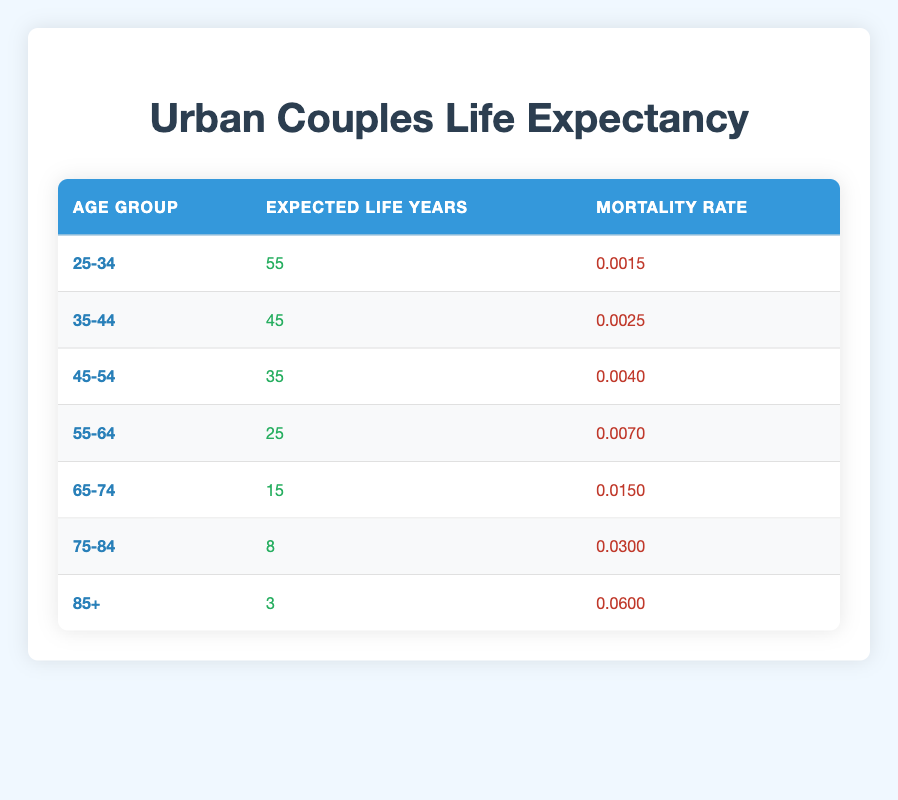What is the expected life span for couples aged 25-34? The table shows that for the age group 25-34, the expected life years are listed as 55. Therefore, the expected life span for this age group is 55 years.
Answer: 55 years What is the highest mortality rate among the age groups listed? By reviewing the mortality rates for each age group, the highest value is found in the age group 85+, which has a mortality rate of 0.0600.
Answer: 0.0600 How many total life years can couples expect to live from ages 35-54 combined? To find the total life years for age groups 35-44 and 45-54, we add their expected life years: 45 (from 35-44) + 35 (from 45-54) = 80.
Answer: 80 years Is the expected life years for the age group 55-64 greater than the average expected life years of the age groups provided? The average expected life years can be calculated by summing all expected life years: 55 + 45 + 35 + 25 + 15 + 8 + 3 = 186, then dividing by 7 gives 186 / 7 ≈ 26.57. Since 25 (for 55-64) is less than 26.57, the answer is no, it’s not greater.
Answer: No What is the difference in expected life years between the 45-54 age group and the 65-74 age group? The expected life years for 45-54 is 35 and for 65-74 is 15. To find the difference, subtract 15 from 35: 35 - 15 = 20.
Answer: 20 years What percentage increase is there in expected life years from the 75-84 age group to the 55-64 age group? The expected life years for 55-64 is 25 and for 75-84 is 8. The increase is 25 - 8 = 17. To find the percentage increase relative to 8, use the formula: (17 / 8) * 100 ≈ 212.5%.
Answer: 212.5% Are there any age groups where the expected life years is less than the associated mortality rate value? By comparing the expected life years to the mortality rates, we find for age groups 25-34 (55 < 0.0015), 35-44 (45 < 0.0025), 45-54 (35 < 0.004), and 55-64 (25 < 0.007) do not meet this condition. However, for the age group 85+, 3 is indeed less than 0.0600, so the answer is no for others and yes for this group.
Answer: Yes How many life years do couples aged 65-74 have remaining compared to those aged 75-84? From the table, couples aged 65-74 have 15 expected life years while those aged 75-84 have 8. To find out how many more years, subtract 8 from 15: 15 - 8 = 7.
Answer: 7 years What is the total expected life years across all age groups listed? To find the total expected life years, we add all the respective values: 55 + 45 + 35 + 25 + 15 + 8 + 3 = 186.
Answer: 186 years 